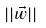Convert formula to latex. <formula><loc_0><loc_0><loc_500><loc_500>| | \vec { w } | |</formula> 